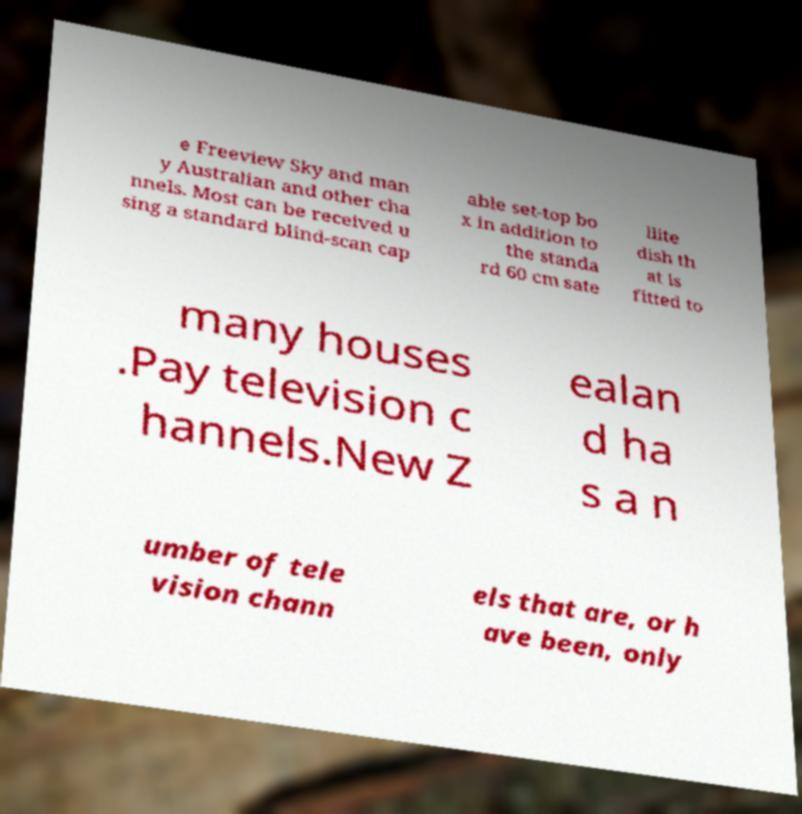For documentation purposes, I need the text within this image transcribed. Could you provide that? e Freeview Sky and man y Australian and other cha nnels. Most can be received u sing a standard blind-scan cap able set-top bo x in addition to the standa rd 60 cm sate llite dish th at is fitted to many houses .Pay television c hannels.New Z ealan d ha s a n umber of tele vision chann els that are, or h ave been, only 